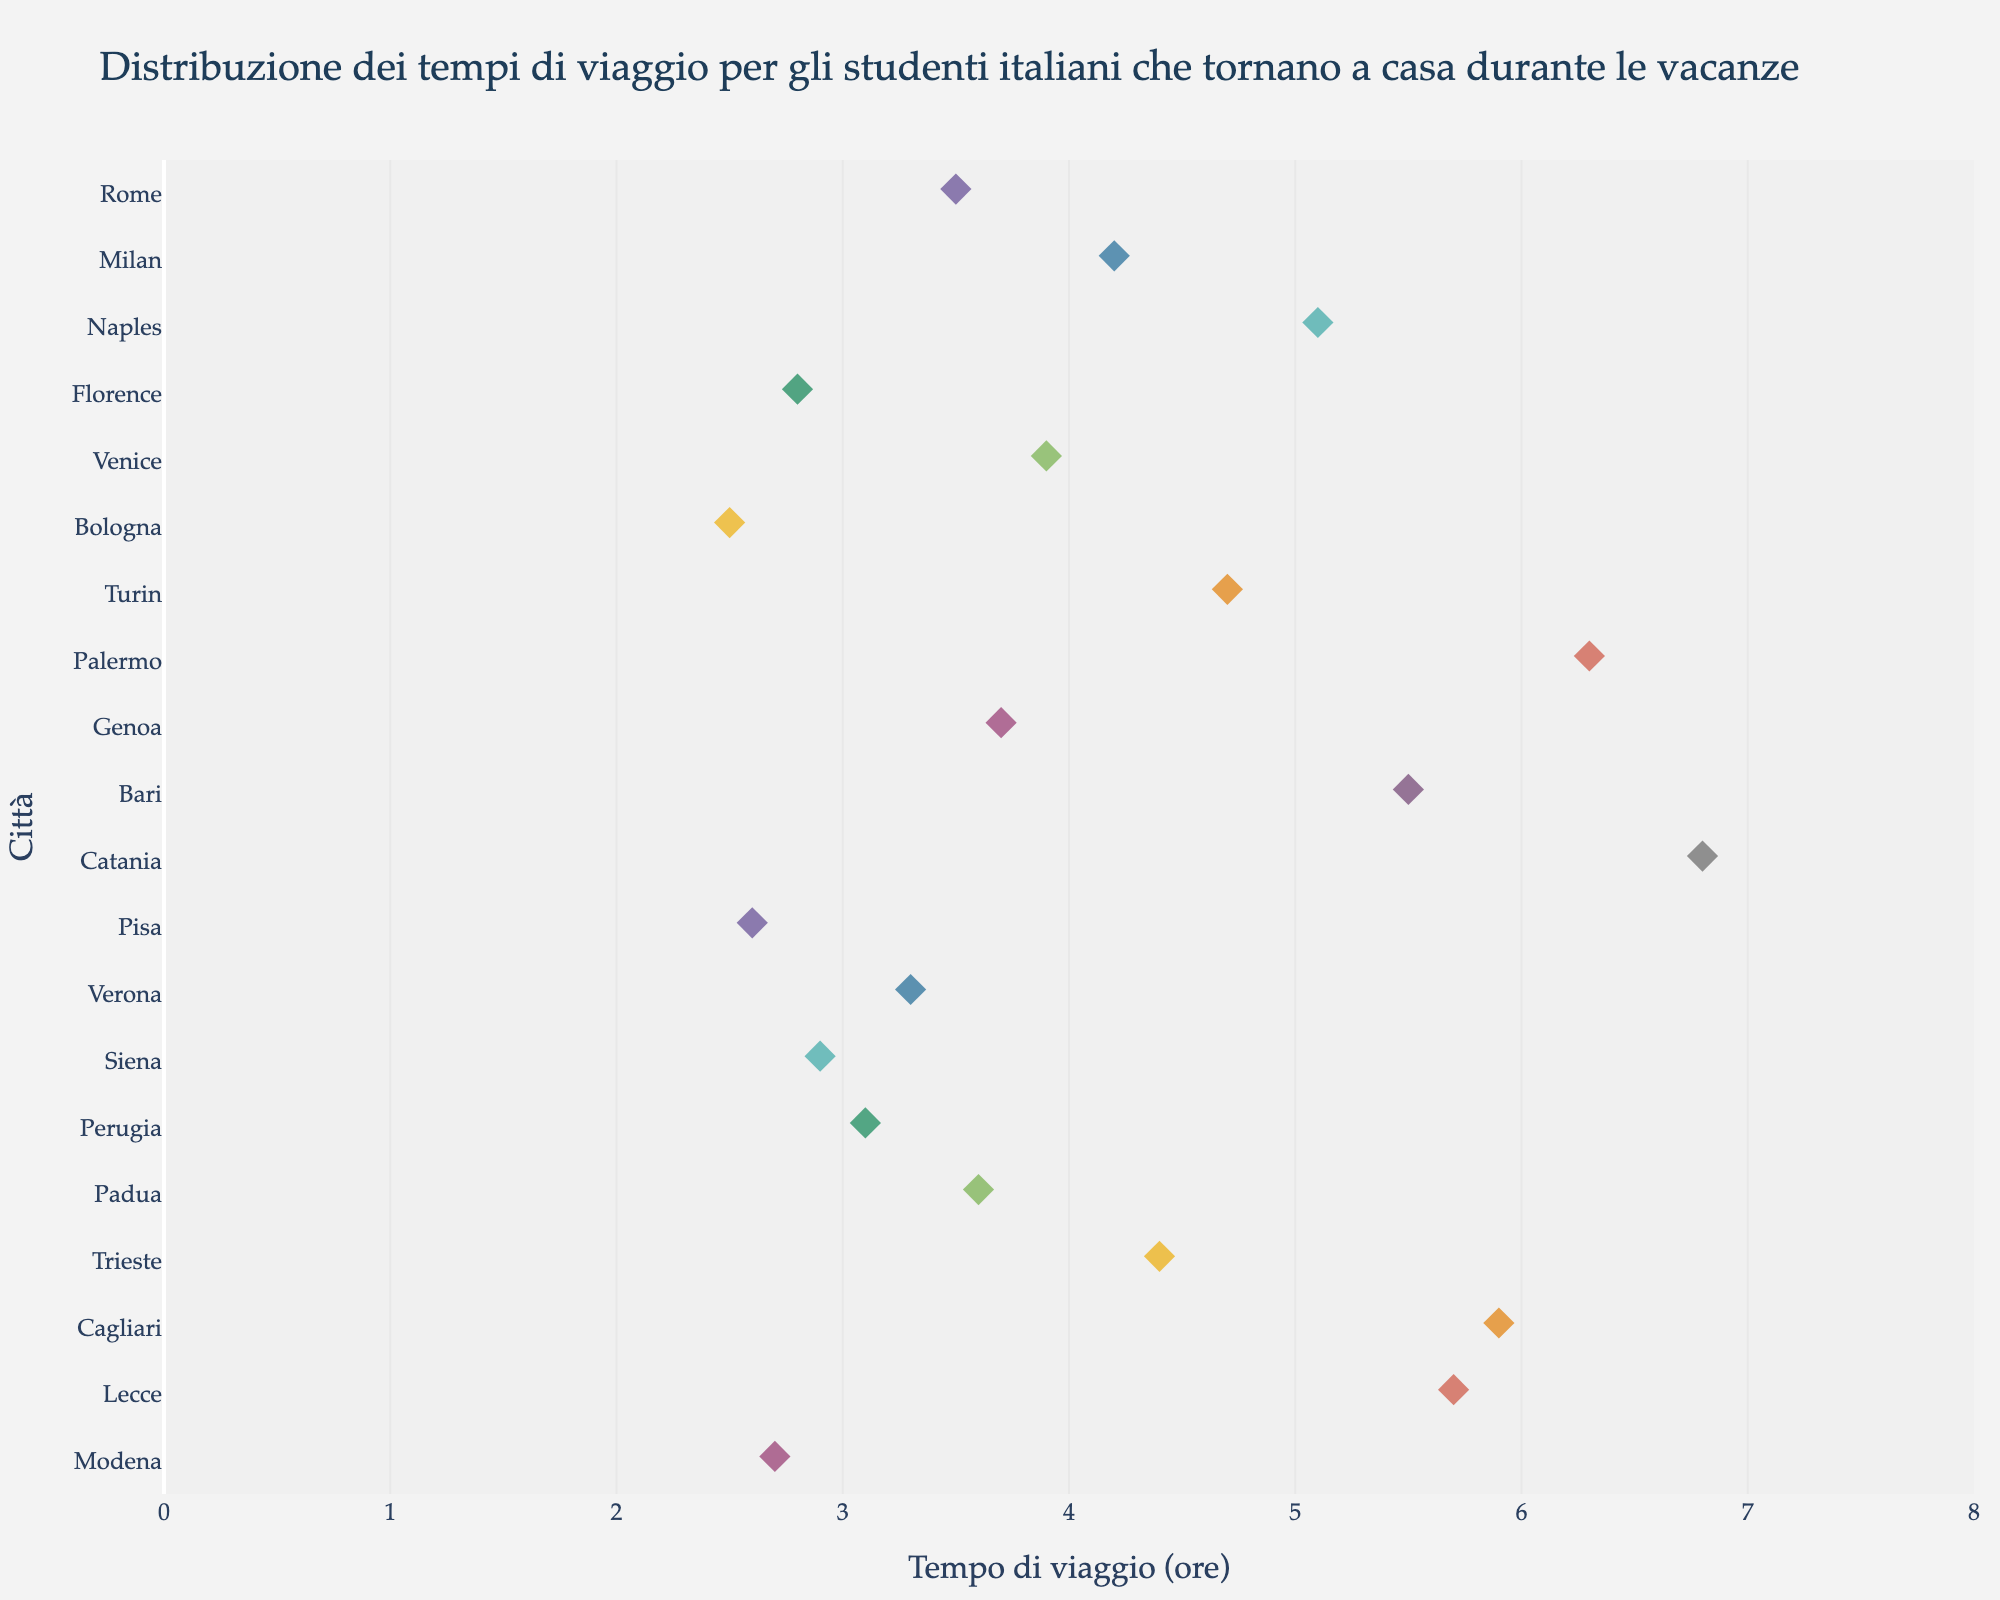What is the title of the plot? The title of the plot is located at the top of the figure and provides a brief description of what the plot is about.
Answer: Distribuzione dei tempi di viaggio per gli studenti italiani che tornano a casa durante le vacanze Which city has the longest travel time? To determine the city with the longest travel time, look for the data point that is furthest to the right on the x-axis.
Answer: Catania How many cities have a travel time greater than 4 hours? Identify and count all data points to the right of the 4-hour mark on the x-axis.
Answer: 8 Which city has a travel time that approaches but does not exceed 3 hours? Find the data point that is closest to but does not exceed the 3-hour mark on the x-axis.
Answer: Siena What's the difference in travel time between Florence and Palermo? Locate the travel times for Florence (2.8 hours) and Palermo (6.3 hours) on the x-axis, then subtract the former from the latter. 6.3 - 2.8 = 3.5
Answer: 3.5 hours What is the median travel time for all cities? To find the median, list all the travel times, order them from least to greatest, and identify the middle value. For 20 data points, the median is the average of the 10th and 11th values. The 10th and 11th values are Genoa (3.7 hours) and Padua (3.6 hours), so the median is (3.7 + 3.6) / 2 = 3.65 hours.
Answer: 3.65 hours Which two cities have the closest travel times? Identify the pair of data points that are closest together on the x-axis.
Answer: Genoa and Padua Are there more cities with travel times below 4 hours or above 4 hours? Count the number of data points to the left of the 4-hour mark and the number to the right. There are 12 cities with travel times below 4 hours and 8 cities with travel times above 4 hours.
Answer: Below 4 hours Is there a city with a travel time exactly at 3.5 hours? Look for a data point exactly at the 3.5-hour mark on the x-axis.
Answer: Yes, Rome Which city has a travel time closest to the average of all the cities? First, calculate the average travel time by summing all travel times and dividing by the number of cities (73.7 / 20 = 3.685). Then, identify the city with a travel time closest to this average.
Answer: Genoa 